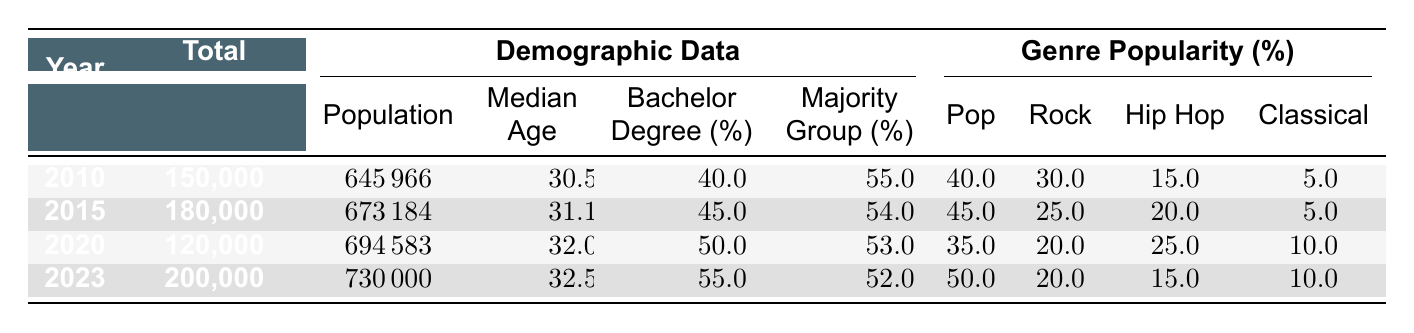What was the total attendance at concerts in 2015? The table shows the total attendance for each year, and for 2015, it states 180,000.
Answer: 180,000 In which year did the median age of the population increase the most? By comparing the median age values, we see that it increased from 30.5 in 2010 to 31.1 in 2015, and then from 31.1 to 32.0 in 2020, which is a 0.9 increase between 2015 and 2020. Comparing these increases, the largest rise was from 2015 to 2020.
Answer: 2015 to 2020 What percentage of concert attendees in 2023 were aged 18-24? According to the demographic data for 2023, 35% of the total audience was aged 18-24.
Answer: 35% Was there a decline in total concert attendance from 2015 to 2020? The table lists total attendance: 180,000 in 2015 and 120,000 in 2020. Since 120,000 is less than 180,000, we confirm there was indeed a decline in total attendance during this period.
Answer: Yes What is the average percentage of attendees aged 25-34 across all years? The percentages for age 25-34 in the years provided are 35 (2010), 40 (2015), 35 (2020), and 40 (2023). The average is calculated as (35 + 40 + 35 + 40) / 4 = 37.5.
Answer: 37.5 Which genre was the most popular in 2023? The genre percentages for 2023 show that pop accounted for 50%. As it's the highest percentage among all genres listed in that year, we conclude that pop was the most popular.
Answer: Pop What was the total population of Boston in 2020? The demographic data for 2020 indicates that the population was 694,583.
Answer: 694,583 How did the percentage of attendees aged 55+ change from 2010 to 2023? The table indicates 10% of attendees were aged 55+ in 2010 and 5% in 2023. The change calculated is 10% - 5% = 5%, showing a decrease.
Answer: Decrease of 5% 